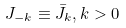Convert formula to latex. <formula><loc_0><loc_0><loc_500><loc_500>J _ { - k } \equiv \bar { J } _ { k } , k > 0</formula> 